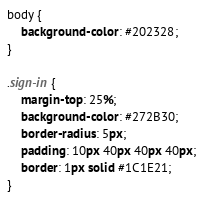<code> <loc_0><loc_0><loc_500><loc_500><_CSS_>body {
	background-color: #202328;
}

.sign-in {
	margin-top: 25%;
	background-color: #272B30;
	border-radius: 5px;
	padding: 10px 40px 40px 40px;
	border: 1px solid #1C1E21;
}</code> 